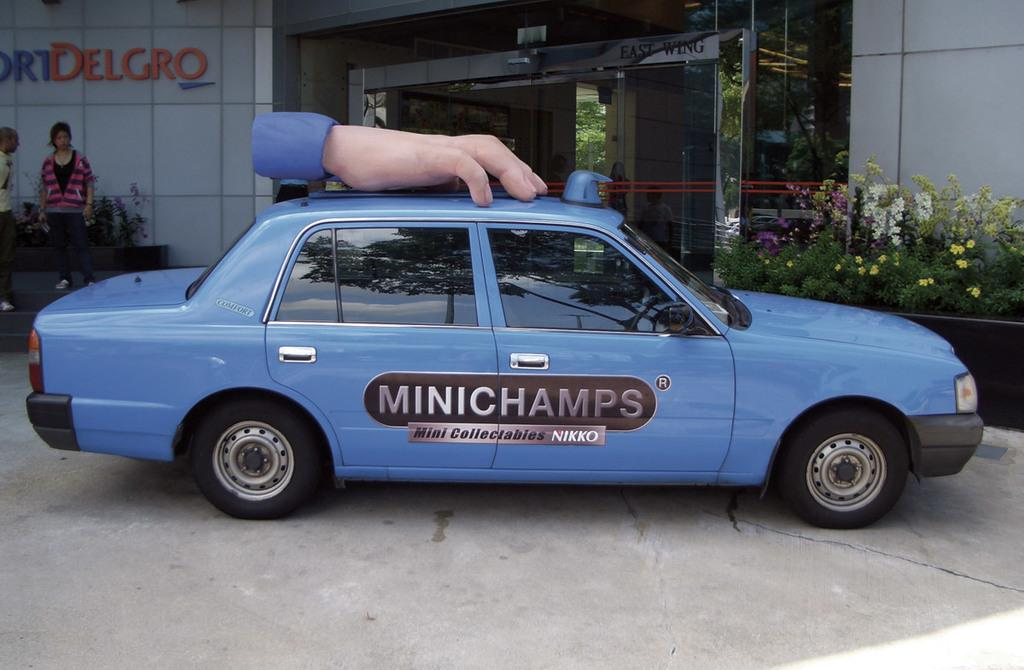<image>
Relay a brief, clear account of the picture shown. a MINIChamps taxi waiting in front of a business 